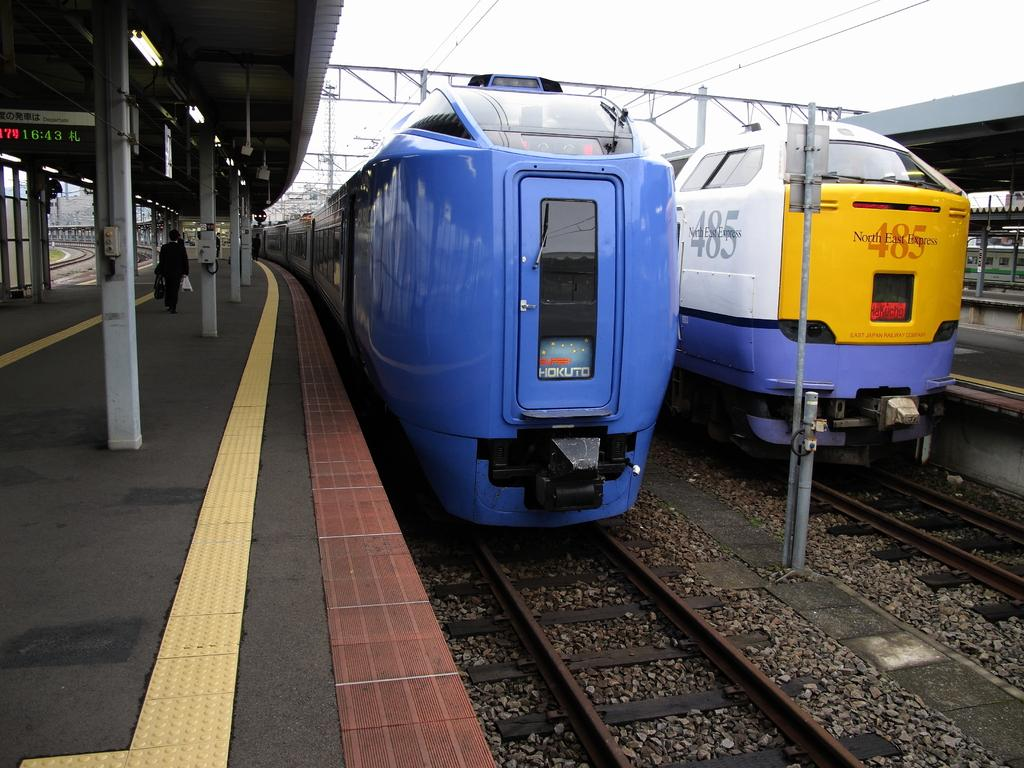Provide a one-sentence caption for the provided image. The 485 North East Express train sits at the train station. 